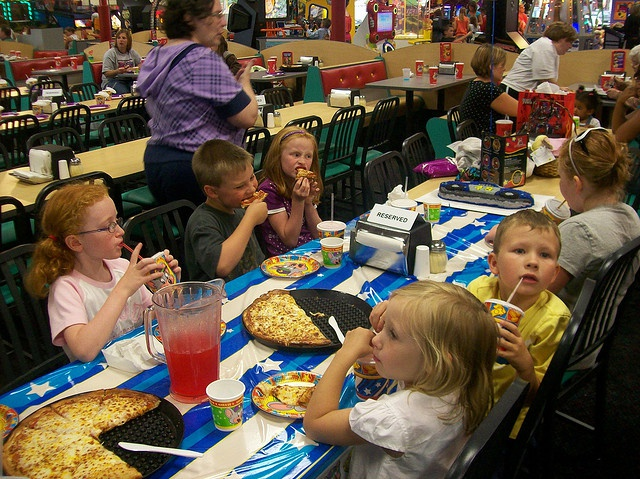Describe the objects in this image and their specific colors. I can see dining table in green, black, beige, and blue tones, cup in green, black, maroon, and gray tones, people in green, black, maroon, and gray tones, people in green, black, purple, and gray tones, and people in green, brown, maroon, and tan tones in this image. 